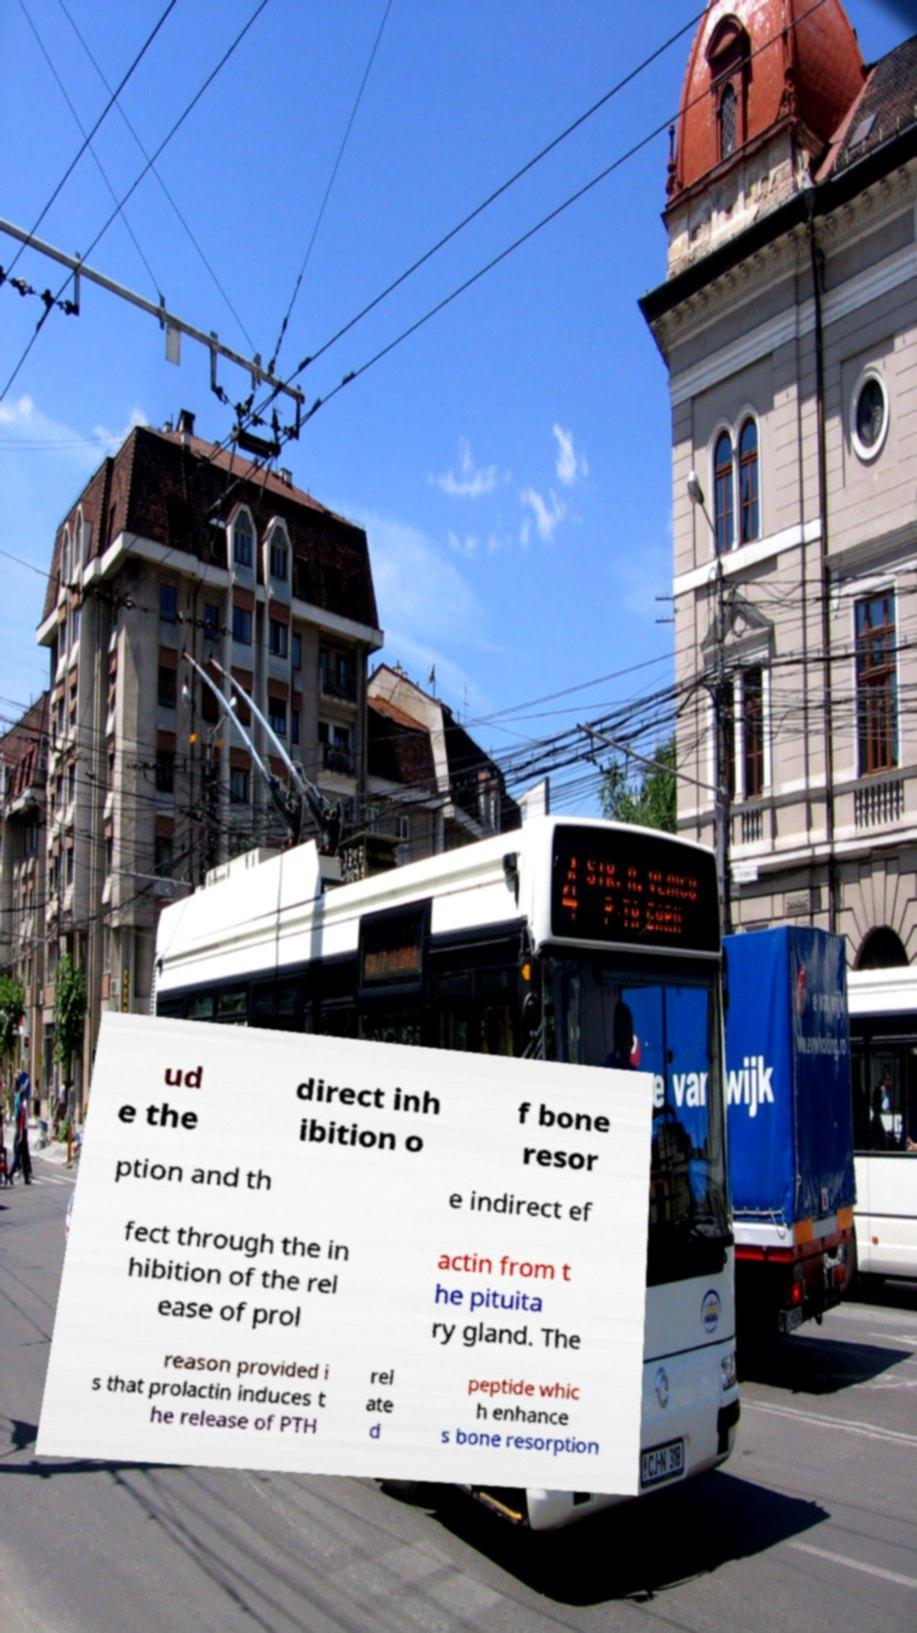Please read and relay the text visible in this image. What does it say? ud e the direct inh ibition o f bone resor ption and th e indirect ef fect through the in hibition of the rel ease of prol actin from t he pituita ry gland. The reason provided i s that prolactin induces t he release of PTH rel ate d peptide whic h enhance s bone resorption 